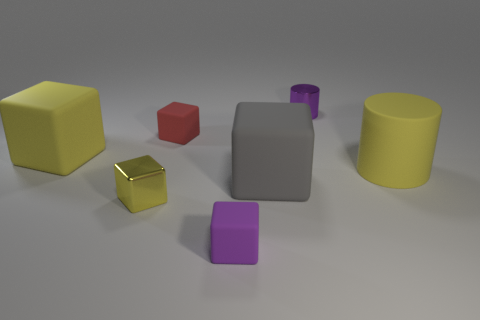The small thing that is both right of the small red block and in front of the purple shiny cylinder is made of what material?
Make the answer very short. Rubber. Is the metallic cylinder the same size as the gray rubber object?
Offer a very short reply. No. There is a yellow metal thing left of the small purple object behind the big yellow block; what is its size?
Your answer should be compact. Small. How many matte objects are both behind the big gray rubber thing and to the right of the purple matte block?
Provide a short and direct response. 1. There is a red cube to the right of the matte thing that is to the left of the metal cube; are there any large yellow matte blocks that are behind it?
Give a very brief answer. No. There is a purple shiny object that is the same size as the red object; what is its shape?
Keep it short and to the point. Cylinder. Is there a small metal cube that has the same color as the big cylinder?
Keep it short and to the point. Yes. Is the gray matte object the same shape as the purple shiny object?
Make the answer very short. No. What number of big things are either gray rubber objects or metallic things?
Give a very brief answer. 1. There is a cylinder that is made of the same material as the red object; what color is it?
Your answer should be very brief. Yellow. 